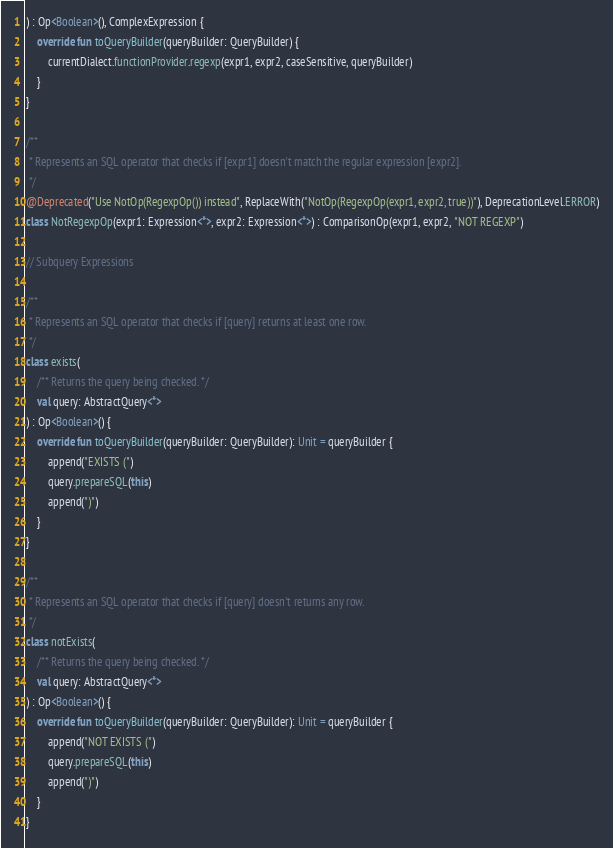<code> <loc_0><loc_0><loc_500><loc_500><_Kotlin_>) : Op<Boolean>(), ComplexExpression {
    override fun toQueryBuilder(queryBuilder: QueryBuilder) {
        currentDialect.functionProvider.regexp(expr1, expr2, caseSensitive, queryBuilder)
    }
}

/**
 * Represents an SQL operator that checks if [expr1] doesn't match the regular expression [expr2].
 */
@Deprecated("Use NotOp(RegexpOp()) instead", ReplaceWith("NotOp(RegexpOp(expr1, expr2, true))"), DeprecationLevel.ERROR)
class NotRegexpOp(expr1: Expression<*>, expr2: Expression<*>) : ComparisonOp(expr1, expr2, "NOT REGEXP")

// Subquery Expressions

/**
 * Represents an SQL operator that checks if [query] returns at least one row.
 */
class exists(
    /** Returns the query being checked. */
    val query: AbstractQuery<*>
) : Op<Boolean>() {
    override fun toQueryBuilder(queryBuilder: QueryBuilder): Unit = queryBuilder {
        append("EXISTS (")
        query.prepareSQL(this)
        append(")")
    }
}

/**
 * Represents an SQL operator that checks if [query] doesn't returns any row.
 */
class notExists(
    /** Returns the query being checked. */
    val query: AbstractQuery<*>
) : Op<Boolean>() {
    override fun toQueryBuilder(queryBuilder: QueryBuilder): Unit = queryBuilder {
        append("NOT EXISTS (")
        query.prepareSQL(this)
        append(")")
    }
}
</code> 